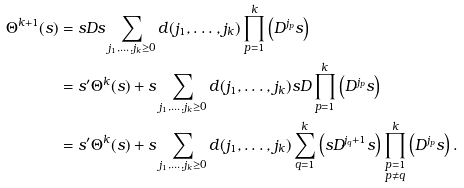<formula> <loc_0><loc_0><loc_500><loc_500>\Theta ^ { k + 1 } ( s ) & = s D s \sum _ { j _ { 1 } , \dots , j _ { k } \geq 0 } d ( j _ { 1 } , \dots , j _ { k } ) \prod _ { p = 1 } ^ { k } \left ( D ^ { j _ { p } } s \right ) \\ & = s ^ { \prime } \Theta ^ { k } ( s ) + s \sum _ { j _ { 1 } , \dots , j _ { k } \geq 0 } d ( j _ { 1 } , \dots , j _ { k } ) s D \prod _ { p = 1 } ^ { k } \left ( D ^ { j _ { p } } s \right ) \\ & = s ^ { \prime } \Theta ^ { k } ( s ) + s \sum _ { j _ { 1 } , \dots , j _ { k } \geq 0 } d ( j _ { 1 } , \dots , j _ { k } ) \sum _ { q = 1 } ^ { k } \left ( s D ^ { j _ { q } + 1 } s \right ) \prod _ { \substack { p = 1 \\ p \ne q } } ^ { k } \left ( D ^ { j _ { p } } s \right ) .</formula> 